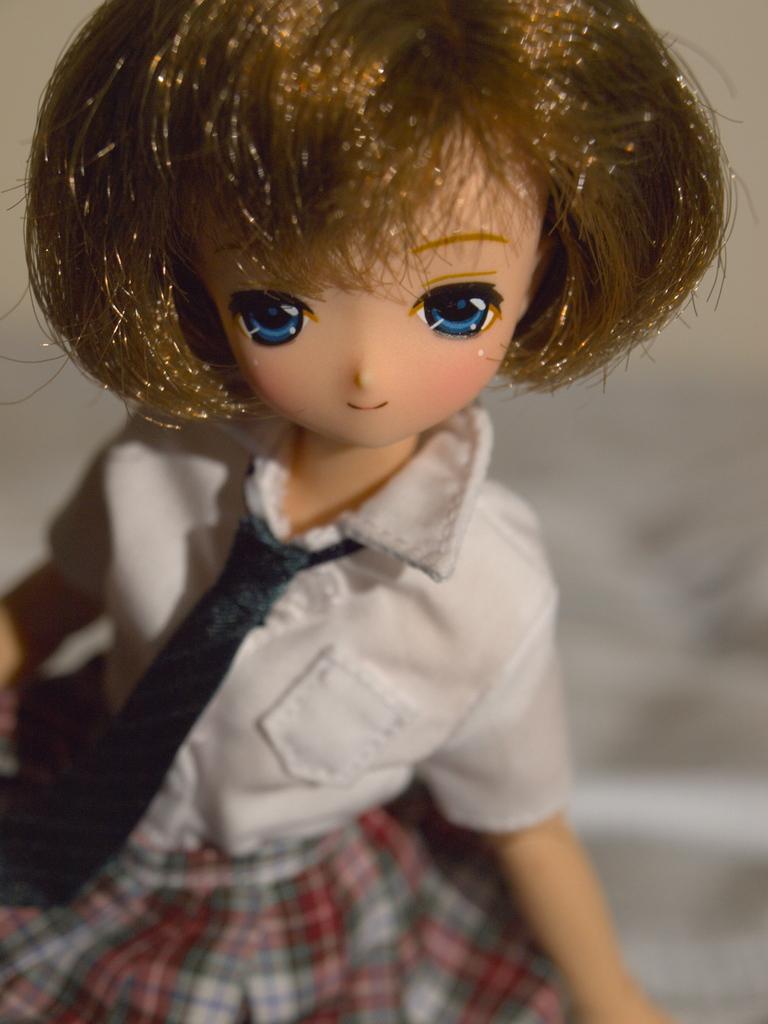In one or two sentences, can you explain what this image depicts? In this image in the foreground there is one toy. 